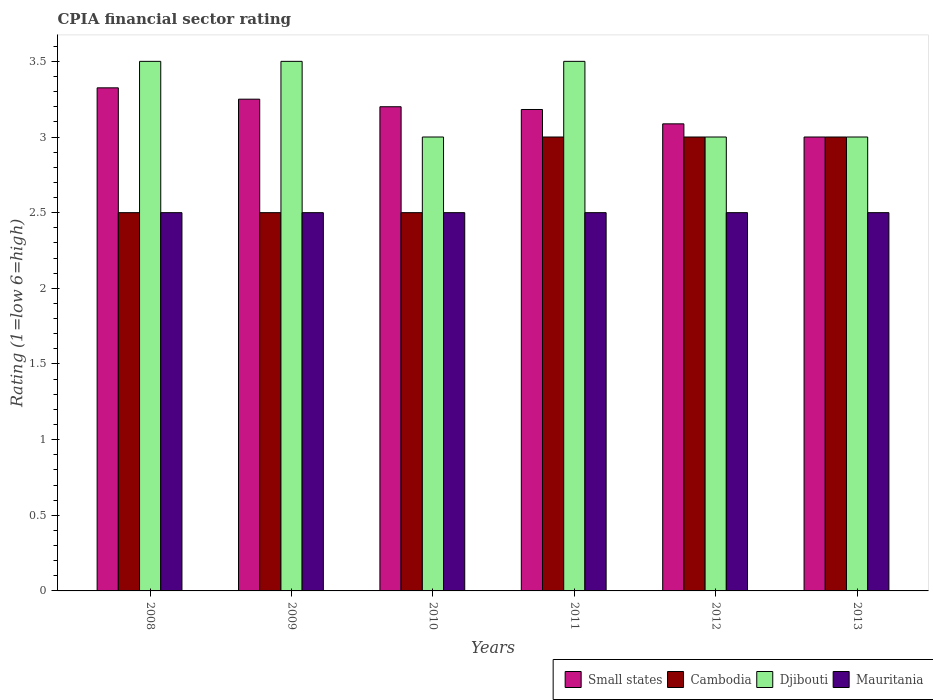Are the number of bars on each tick of the X-axis equal?
Your answer should be compact. Yes. How many bars are there on the 3rd tick from the right?
Make the answer very short. 4. In how many cases, is the number of bars for a given year not equal to the number of legend labels?
Your answer should be very brief. 0. What is the CPIA rating in Mauritania in 2009?
Keep it short and to the point. 2.5. Across all years, what is the maximum CPIA rating in Mauritania?
Your response must be concise. 2.5. Across all years, what is the minimum CPIA rating in Djibouti?
Your answer should be compact. 3. In which year was the CPIA rating in Mauritania maximum?
Offer a very short reply. 2008. What is the total CPIA rating in Small states in the graph?
Offer a terse response. 19.04. What is the difference between the CPIA rating in Small states in 2008 and the CPIA rating in Djibouti in 2013?
Your response must be concise. 0.33. What is the average CPIA rating in Small states per year?
Offer a very short reply. 3.17. In the year 2010, what is the difference between the CPIA rating in Small states and CPIA rating in Mauritania?
Make the answer very short. 0.7. In how many years, is the CPIA rating in Mauritania greater than 2?
Provide a succinct answer. 6. What is the ratio of the CPIA rating in Cambodia in 2008 to that in 2009?
Your response must be concise. 1. Is the CPIA rating in Cambodia in 2011 less than that in 2012?
Your response must be concise. No. Is the difference between the CPIA rating in Small states in 2008 and 2011 greater than the difference between the CPIA rating in Mauritania in 2008 and 2011?
Make the answer very short. Yes. What is the difference between the highest and the second highest CPIA rating in Djibouti?
Give a very brief answer. 0. What is the difference between the highest and the lowest CPIA rating in Mauritania?
Ensure brevity in your answer.  0. In how many years, is the CPIA rating in Small states greater than the average CPIA rating in Small states taken over all years?
Keep it short and to the point. 4. Is the sum of the CPIA rating in Small states in 2010 and 2013 greater than the maximum CPIA rating in Mauritania across all years?
Give a very brief answer. Yes. Is it the case that in every year, the sum of the CPIA rating in Djibouti and CPIA rating in Small states is greater than the sum of CPIA rating in Mauritania and CPIA rating in Cambodia?
Offer a very short reply. Yes. What does the 4th bar from the left in 2012 represents?
Provide a succinct answer. Mauritania. What does the 2nd bar from the right in 2008 represents?
Offer a terse response. Djibouti. Is it the case that in every year, the sum of the CPIA rating in Mauritania and CPIA rating in Small states is greater than the CPIA rating in Cambodia?
Offer a very short reply. Yes. How many bars are there?
Provide a short and direct response. 24. How many years are there in the graph?
Ensure brevity in your answer.  6. Are the values on the major ticks of Y-axis written in scientific E-notation?
Offer a terse response. No. Does the graph contain any zero values?
Keep it short and to the point. No. Where does the legend appear in the graph?
Your answer should be very brief. Bottom right. How many legend labels are there?
Ensure brevity in your answer.  4. How are the legend labels stacked?
Offer a very short reply. Horizontal. What is the title of the graph?
Offer a terse response. CPIA financial sector rating. What is the Rating (1=low 6=high) in Small states in 2008?
Offer a terse response. 3.33. What is the Rating (1=low 6=high) in Djibouti in 2008?
Provide a short and direct response. 3.5. What is the Rating (1=low 6=high) in Small states in 2009?
Provide a short and direct response. 3.25. What is the Rating (1=low 6=high) of Djibouti in 2009?
Offer a terse response. 3.5. What is the Rating (1=low 6=high) in Small states in 2010?
Give a very brief answer. 3.2. What is the Rating (1=low 6=high) of Cambodia in 2010?
Your answer should be compact. 2.5. What is the Rating (1=low 6=high) of Small states in 2011?
Ensure brevity in your answer.  3.18. What is the Rating (1=low 6=high) in Cambodia in 2011?
Keep it short and to the point. 3. What is the Rating (1=low 6=high) of Small states in 2012?
Give a very brief answer. 3.09. What is the Rating (1=low 6=high) in Djibouti in 2012?
Offer a very short reply. 3. What is the Rating (1=low 6=high) of Small states in 2013?
Provide a short and direct response. 3. What is the Rating (1=low 6=high) in Cambodia in 2013?
Your answer should be compact. 3. What is the Rating (1=low 6=high) in Mauritania in 2013?
Make the answer very short. 2.5. Across all years, what is the maximum Rating (1=low 6=high) of Small states?
Provide a succinct answer. 3.33. Across all years, what is the maximum Rating (1=low 6=high) in Cambodia?
Your answer should be compact. 3. Across all years, what is the maximum Rating (1=low 6=high) in Mauritania?
Your response must be concise. 2.5. Across all years, what is the minimum Rating (1=low 6=high) in Djibouti?
Make the answer very short. 3. What is the total Rating (1=low 6=high) in Small states in the graph?
Offer a terse response. 19.04. What is the total Rating (1=low 6=high) of Cambodia in the graph?
Offer a very short reply. 16.5. What is the difference between the Rating (1=low 6=high) in Small states in 2008 and that in 2009?
Your answer should be compact. 0.07. What is the difference between the Rating (1=low 6=high) in Mauritania in 2008 and that in 2009?
Your response must be concise. 0. What is the difference between the Rating (1=low 6=high) in Small states in 2008 and that in 2010?
Provide a short and direct response. 0.12. What is the difference between the Rating (1=low 6=high) of Cambodia in 2008 and that in 2010?
Your response must be concise. 0. What is the difference between the Rating (1=low 6=high) in Mauritania in 2008 and that in 2010?
Keep it short and to the point. 0. What is the difference between the Rating (1=low 6=high) of Small states in 2008 and that in 2011?
Keep it short and to the point. 0.14. What is the difference between the Rating (1=low 6=high) of Small states in 2008 and that in 2012?
Your response must be concise. 0.24. What is the difference between the Rating (1=low 6=high) in Small states in 2008 and that in 2013?
Provide a short and direct response. 0.33. What is the difference between the Rating (1=low 6=high) of Cambodia in 2008 and that in 2013?
Your answer should be compact. -0.5. What is the difference between the Rating (1=low 6=high) in Djibouti in 2008 and that in 2013?
Your answer should be very brief. 0.5. What is the difference between the Rating (1=low 6=high) of Small states in 2009 and that in 2010?
Provide a short and direct response. 0.05. What is the difference between the Rating (1=low 6=high) of Cambodia in 2009 and that in 2010?
Offer a very short reply. 0. What is the difference between the Rating (1=low 6=high) in Djibouti in 2009 and that in 2010?
Your answer should be compact. 0.5. What is the difference between the Rating (1=low 6=high) of Mauritania in 2009 and that in 2010?
Provide a short and direct response. 0. What is the difference between the Rating (1=low 6=high) in Small states in 2009 and that in 2011?
Ensure brevity in your answer.  0.07. What is the difference between the Rating (1=low 6=high) in Djibouti in 2009 and that in 2011?
Keep it short and to the point. 0. What is the difference between the Rating (1=low 6=high) in Small states in 2009 and that in 2012?
Your answer should be compact. 0.16. What is the difference between the Rating (1=low 6=high) in Djibouti in 2009 and that in 2012?
Your response must be concise. 0.5. What is the difference between the Rating (1=low 6=high) of Mauritania in 2009 and that in 2012?
Make the answer very short. 0. What is the difference between the Rating (1=low 6=high) of Small states in 2009 and that in 2013?
Your answer should be very brief. 0.25. What is the difference between the Rating (1=low 6=high) in Cambodia in 2009 and that in 2013?
Provide a short and direct response. -0.5. What is the difference between the Rating (1=low 6=high) of Small states in 2010 and that in 2011?
Your answer should be very brief. 0.02. What is the difference between the Rating (1=low 6=high) of Djibouti in 2010 and that in 2011?
Offer a very short reply. -0.5. What is the difference between the Rating (1=low 6=high) in Small states in 2010 and that in 2012?
Provide a short and direct response. 0.11. What is the difference between the Rating (1=low 6=high) of Mauritania in 2010 and that in 2012?
Your answer should be very brief. 0. What is the difference between the Rating (1=low 6=high) in Mauritania in 2010 and that in 2013?
Offer a very short reply. 0. What is the difference between the Rating (1=low 6=high) in Small states in 2011 and that in 2012?
Offer a terse response. 0.09. What is the difference between the Rating (1=low 6=high) in Cambodia in 2011 and that in 2012?
Ensure brevity in your answer.  0. What is the difference between the Rating (1=low 6=high) in Small states in 2011 and that in 2013?
Offer a terse response. 0.18. What is the difference between the Rating (1=low 6=high) of Cambodia in 2011 and that in 2013?
Offer a terse response. 0. What is the difference between the Rating (1=low 6=high) in Djibouti in 2011 and that in 2013?
Offer a terse response. 0.5. What is the difference between the Rating (1=low 6=high) of Mauritania in 2011 and that in 2013?
Keep it short and to the point. 0. What is the difference between the Rating (1=low 6=high) of Small states in 2012 and that in 2013?
Give a very brief answer. 0.09. What is the difference between the Rating (1=low 6=high) of Mauritania in 2012 and that in 2013?
Your answer should be compact. 0. What is the difference between the Rating (1=low 6=high) of Small states in 2008 and the Rating (1=low 6=high) of Cambodia in 2009?
Give a very brief answer. 0.82. What is the difference between the Rating (1=low 6=high) of Small states in 2008 and the Rating (1=low 6=high) of Djibouti in 2009?
Offer a terse response. -0.17. What is the difference between the Rating (1=low 6=high) of Small states in 2008 and the Rating (1=low 6=high) of Mauritania in 2009?
Provide a short and direct response. 0.82. What is the difference between the Rating (1=low 6=high) of Cambodia in 2008 and the Rating (1=low 6=high) of Mauritania in 2009?
Offer a terse response. 0. What is the difference between the Rating (1=low 6=high) in Small states in 2008 and the Rating (1=low 6=high) in Cambodia in 2010?
Your response must be concise. 0.82. What is the difference between the Rating (1=low 6=high) in Small states in 2008 and the Rating (1=low 6=high) in Djibouti in 2010?
Provide a succinct answer. 0.33. What is the difference between the Rating (1=low 6=high) in Small states in 2008 and the Rating (1=low 6=high) in Mauritania in 2010?
Give a very brief answer. 0.82. What is the difference between the Rating (1=low 6=high) in Small states in 2008 and the Rating (1=low 6=high) in Cambodia in 2011?
Keep it short and to the point. 0.33. What is the difference between the Rating (1=low 6=high) in Small states in 2008 and the Rating (1=low 6=high) in Djibouti in 2011?
Ensure brevity in your answer.  -0.17. What is the difference between the Rating (1=low 6=high) in Small states in 2008 and the Rating (1=low 6=high) in Mauritania in 2011?
Your answer should be very brief. 0.82. What is the difference between the Rating (1=low 6=high) of Cambodia in 2008 and the Rating (1=low 6=high) of Mauritania in 2011?
Offer a very short reply. 0. What is the difference between the Rating (1=low 6=high) in Djibouti in 2008 and the Rating (1=low 6=high) in Mauritania in 2011?
Make the answer very short. 1. What is the difference between the Rating (1=low 6=high) of Small states in 2008 and the Rating (1=low 6=high) of Cambodia in 2012?
Provide a short and direct response. 0.33. What is the difference between the Rating (1=low 6=high) of Small states in 2008 and the Rating (1=low 6=high) of Djibouti in 2012?
Your answer should be compact. 0.33. What is the difference between the Rating (1=low 6=high) in Small states in 2008 and the Rating (1=low 6=high) in Mauritania in 2012?
Provide a succinct answer. 0.82. What is the difference between the Rating (1=low 6=high) of Cambodia in 2008 and the Rating (1=low 6=high) of Djibouti in 2012?
Offer a very short reply. -0.5. What is the difference between the Rating (1=low 6=high) in Small states in 2008 and the Rating (1=low 6=high) in Cambodia in 2013?
Provide a succinct answer. 0.33. What is the difference between the Rating (1=low 6=high) of Small states in 2008 and the Rating (1=low 6=high) of Djibouti in 2013?
Make the answer very short. 0.33. What is the difference between the Rating (1=low 6=high) of Small states in 2008 and the Rating (1=low 6=high) of Mauritania in 2013?
Offer a very short reply. 0.82. What is the difference between the Rating (1=low 6=high) in Cambodia in 2008 and the Rating (1=low 6=high) in Djibouti in 2013?
Make the answer very short. -0.5. What is the difference between the Rating (1=low 6=high) of Djibouti in 2008 and the Rating (1=low 6=high) of Mauritania in 2013?
Give a very brief answer. 1. What is the difference between the Rating (1=low 6=high) in Small states in 2009 and the Rating (1=low 6=high) in Cambodia in 2010?
Your answer should be very brief. 0.75. What is the difference between the Rating (1=low 6=high) of Small states in 2009 and the Rating (1=low 6=high) of Djibouti in 2010?
Provide a succinct answer. 0.25. What is the difference between the Rating (1=low 6=high) in Small states in 2009 and the Rating (1=low 6=high) in Mauritania in 2010?
Keep it short and to the point. 0.75. What is the difference between the Rating (1=low 6=high) in Djibouti in 2009 and the Rating (1=low 6=high) in Mauritania in 2010?
Provide a short and direct response. 1. What is the difference between the Rating (1=low 6=high) of Small states in 2009 and the Rating (1=low 6=high) of Cambodia in 2011?
Your response must be concise. 0.25. What is the difference between the Rating (1=low 6=high) in Small states in 2009 and the Rating (1=low 6=high) in Mauritania in 2011?
Your response must be concise. 0.75. What is the difference between the Rating (1=low 6=high) in Cambodia in 2009 and the Rating (1=low 6=high) in Djibouti in 2011?
Ensure brevity in your answer.  -1. What is the difference between the Rating (1=low 6=high) of Cambodia in 2009 and the Rating (1=low 6=high) of Mauritania in 2011?
Provide a short and direct response. 0. What is the difference between the Rating (1=low 6=high) of Djibouti in 2009 and the Rating (1=low 6=high) of Mauritania in 2011?
Give a very brief answer. 1. What is the difference between the Rating (1=low 6=high) of Small states in 2009 and the Rating (1=low 6=high) of Djibouti in 2012?
Offer a terse response. 0.25. What is the difference between the Rating (1=low 6=high) in Small states in 2009 and the Rating (1=low 6=high) in Cambodia in 2013?
Ensure brevity in your answer.  0.25. What is the difference between the Rating (1=low 6=high) in Small states in 2009 and the Rating (1=low 6=high) in Djibouti in 2013?
Keep it short and to the point. 0.25. What is the difference between the Rating (1=low 6=high) in Cambodia in 2009 and the Rating (1=low 6=high) in Mauritania in 2013?
Provide a succinct answer. 0. What is the difference between the Rating (1=low 6=high) in Cambodia in 2010 and the Rating (1=low 6=high) in Djibouti in 2011?
Keep it short and to the point. -1. What is the difference between the Rating (1=low 6=high) in Cambodia in 2010 and the Rating (1=low 6=high) in Mauritania in 2011?
Offer a terse response. 0. What is the difference between the Rating (1=low 6=high) of Djibouti in 2010 and the Rating (1=low 6=high) of Mauritania in 2011?
Give a very brief answer. 0.5. What is the difference between the Rating (1=low 6=high) in Cambodia in 2010 and the Rating (1=low 6=high) in Djibouti in 2012?
Ensure brevity in your answer.  -0.5. What is the difference between the Rating (1=low 6=high) in Djibouti in 2010 and the Rating (1=low 6=high) in Mauritania in 2012?
Your answer should be very brief. 0.5. What is the difference between the Rating (1=low 6=high) in Small states in 2010 and the Rating (1=low 6=high) in Cambodia in 2013?
Make the answer very short. 0.2. What is the difference between the Rating (1=low 6=high) in Small states in 2010 and the Rating (1=low 6=high) in Mauritania in 2013?
Offer a terse response. 0.7. What is the difference between the Rating (1=low 6=high) in Djibouti in 2010 and the Rating (1=low 6=high) in Mauritania in 2013?
Give a very brief answer. 0.5. What is the difference between the Rating (1=low 6=high) in Small states in 2011 and the Rating (1=low 6=high) in Cambodia in 2012?
Give a very brief answer. 0.18. What is the difference between the Rating (1=low 6=high) of Small states in 2011 and the Rating (1=low 6=high) of Djibouti in 2012?
Provide a succinct answer. 0.18. What is the difference between the Rating (1=low 6=high) in Small states in 2011 and the Rating (1=low 6=high) in Mauritania in 2012?
Offer a terse response. 0.68. What is the difference between the Rating (1=low 6=high) of Cambodia in 2011 and the Rating (1=low 6=high) of Djibouti in 2012?
Give a very brief answer. 0. What is the difference between the Rating (1=low 6=high) of Djibouti in 2011 and the Rating (1=low 6=high) of Mauritania in 2012?
Offer a terse response. 1. What is the difference between the Rating (1=low 6=high) in Small states in 2011 and the Rating (1=low 6=high) in Cambodia in 2013?
Ensure brevity in your answer.  0.18. What is the difference between the Rating (1=low 6=high) in Small states in 2011 and the Rating (1=low 6=high) in Djibouti in 2013?
Keep it short and to the point. 0.18. What is the difference between the Rating (1=low 6=high) in Small states in 2011 and the Rating (1=low 6=high) in Mauritania in 2013?
Your response must be concise. 0.68. What is the difference between the Rating (1=low 6=high) of Small states in 2012 and the Rating (1=low 6=high) of Cambodia in 2013?
Give a very brief answer. 0.09. What is the difference between the Rating (1=low 6=high) of Small states in 2012 and the Rating (1=low 6=high) of Djibouti in 2013?
Keep it short and to the point. 0.09. What is the difference between the Rating (1=low 6=high) of Small states in 2012 and the Rating (1=low 6=high) of Mauritania in 2013?
Your response must be concise. 0.59. What is the difference between the Rating (1=low 6=high) of Cambodia in 2012 and the Rating (1=low 6=high) of Mauritania in 2013?
Ensure brevity in your answer.  0.5. What is the average Rating (1=low 6=high) in Small states per year?
Your response must be concise. 3.17. What is the average Rating (1=low 6=high) of Cambodia per year?
Offer a very short reply. 2.75. In the year 2008, what is the difference between the Rating (1=low 6=high) in Small states and Rating (1=low 6=high) in Cambodia?
Your response must be concise. 0.82. In the year 2008, what is the difference between the Rating (1=low 6=high) of Small states and Rating (1=low 6=high) of Djibouti?
Give a very brief answer. -0.17. In the year 2008, what is the difference between the Rating (1=low 6=high) of Small states and Rating (1=low 6=high) of Mauritania?
Provide a succinct answer. 0.82. In the year 2008, what is the difference between the Rating (1=low 6=high) of Cambodia and Rating (1=low 6=high) of Mauritania?
Offer a very short reply. 0. In the year 2009, what is the difference between the Rating (1=low 6=high) of Small states and Rating (1=low 6=high) of Cambodia?
Provide a short and direct response. 0.75. In the year 2009, what is the difference between the Rating (1=low 6=high) of Small states and Rating (1=low 6=high) of Djibouti?
Offer a very short reply. -0.25. In the year 2009, what is the difference between the Rating (1=low 6=high) in Small states and Rating (1=low 6=high) in Mauritania?
Offer a terse response. 0.75. In the year 2009, what is the difference between the Rating (1=low 6=high) in Cambodia and Rating (1=low 6=high) in Mauritania?
Provide a succinct answer. 0. In the year 2009, what is the difference between the Rating (1=low 6=high) in Djibouti and Rating (1=low 6=high) in Mauritania?
Your answer should be very brief. 1. In the year 2010, what is the difference between the Rating (1=low 6=high) of Small states and Rating (1=low 6=high) of Cambodia?
Give a very brief answer. 0.7. In the year 2010, what is the difference between the Rating (1=low 6=high) in Cambodia and Rating (1=low 6=high) in Djibouti?
Ensure brevity in your answer.  -0.5. In the year 2010, what is the difference between the Rating (1=low 6=high) in Djibouti and Rating (1=low 6=high) in Mauritania?
Offer a terse response. 0.5. In the year 2011, what is the difference between the Rating (1=low 6=high) in Small states and Rating (1=low 6=high) in Cambodia?
Your answer should be very brief. 0.18. In the year 2011, what is the difference between the Rating (1=low 6=high) in Small states and Rating (1=low 6=high) in Djibouti?
Your answer should be compact. -0.32. In the year 2011, what is the difference between the Rating (1=low 6=high) of Small states and Rating (1=low 6=high) of Mauritania?
Provide a short and direct response. 0.68. In the year 2011, what is the difference between the Rating (1=low 6=high) of Cambodia and Rating (1=low 6=high) of Djibouti?
Offer a very short reply. -0.5. In the year 2011, what is the difference between the Rating (1=low 6=high) in Djibouti and Rating (1=low 6=high) in Mauritania?
Make the answer very short. 1. In the year 2012, what is the difference between the Rating (1=low 6=high) in Small states and Rating (1=low 6=high) in Cambodia?
Offer a very short reply. 0.09. In the year 2012, what is the difference between the Rating (1=low 6=high) in Small states and Rating (1=low 6=high) in Djibouti?
Offer a terse response. 0.09. In the year 2012, what is the difference between the Rating (1=low 6=high) of Small states and Rating (1=low 6=high) of Mauritania?
Provide a short and direct response. 0.59. In the year 2012, what is the difference between the Rating (1=low 6=high) in Djibouti and Rating (1=low 6=high) in Mauritania?
Provide a short and direct response. 0.5. In the year 2013, what is the difference between the Rating (1=low 6=high) of Small states and Rating (1=low 6=high) of Cambodia?
Keep it short and to the point. 0. In the year 2013, what is the difference between the Rating (1=low 6=high) in Small states and Rating (1=low 6=high) in Mauritania?
Your answer should be compact. 0.5. In the year 2013, what is the difference between the Rating (1=low 6=high) in Cambodia and Rating (1=low 6=high) in Djibouti?
Provide a succinct answer. 0. In the year 2013, what is the difference between the Rating (1=low 6=high) of Cambodia and Rating (1=low 6=high) of Mauritania?
Give a very brief answer. 0.5. In the year 2013, what is the difference between the Rating (1=low 6=high) in Djibouti and Rating (1=low 6=high) in Mauritania?
Provide a succinct answer. 0.5. What is the ratio of the Rating (1=low 6=high) of Small states in 2008 to that in 2009?
Provide a short and direct response. 1.02. What is the ratio of the Rating (1=low 6=high) in Cambodia in 2008 to that in 2009?
Make the answer very short. 1. What is the ratio of the Rating (1=low 6=high) of Djibouti in 2008 to that in 2009?
Your response must be concise. 1. What is the ratio of the Rating (1=low 6=high) of Small states in 2008 to that in 2010?
Give a very brief answer. 1.04. What is the ratio of the Rating (1=low 6=high) of Cambodia in 2008 to that in 2010?
Give a very brief answer. 1. What is the ratio of the Rating (1=low 6=high) in Small states in 2008 to that in 2011?
Provide a succinct answer. 1.04. What is the ratio of the Rating (1=low 6=high) of Djibouti in 2008 to that in 2011?
Provide a succinct answer. 1. What is the ratio of the Rating (1=low 6=high) of Small states in 2008 to that in 2012?
Your answer should be very brief. 1.08. What is the ratio of the Rating (1=low 6=high) in Cambodia in 2008 to that in 2012?
Provide a short and direct response. 0.83. What is the ratio of the Rating (1=low 6=high) of Mauritania in 2008 to that in 2012?
Provide a short and direct response. 1. What is the ratio of the Rating (1=low 6=high) in Small states in 2008 to that in 2013?
Your response must be concise. 1.11. What is the ratio of the Rating (1=low 6=high) in Djibouti in 2008 to that in 2013?
Offer a terse response. 1.17. What is the ratio of the Rating (1=low 6=high) in Mauritania in 2008 to that in 2013?
Make the answer very short. 1. What is the ratio of the Rating (1=low 6=high) of Small states in 2009 to that in 2010?
Provide a succinct answer. 1.02. What is the ratio of the Rating (1=low 6=high) in Djibouti in 2009 to that in 2010?
Give a very brief answer. 1.17. What is the ratio of the Rating (1=low 6=high) of Small states in 2009 to that in 2011?
Your answer should be very brief. 1.02. What is the ratio of the Rating (1=low 6=high) of Djibouti in 2009 to that in 2011?
Provide a succinct answer. 1. What is the ratio of the Rating (1=low 6=high) in Mauritania in 2009 to that in 2011?
Keep it short and to the point. 1. What is the ratio of the Rating (1=low 6=high) of Small states in 2009 to that in 2012?
Provide a short and direct response. 1.05. What is the ratio of the Rating (1=low 6=high) in Cambodia in 2009 to that in 2013?
Make the answer very short. 0.83. What is the ratio of the Rating (1=low 6=high) in Mauritania in 2009 to that in 2013?
Offer a terse response. 1. What is the ratio of the Rating (1=low 6=high) in Small states in 2010 to that in 2011?
Keep it short and to the point. 1.01. What is the ratio of the Rating (1=low 6=high) in Cambodia in 2010 to that in 2011?
Make the answer very short. 0.83. What is the ratio of the Rating (1=low 6=high) of Small states in 2010 to that in 2012?
Your response must be concise. 1.04. What is the ratio of the Rating (1=low 6=high) in Djibouti in 2010 to that in 2012?
Your response must be concise. 1. What is the ratio of the Rating (1=low 6=high) in Mauritania in 2010 to that in 2012?
Give a very brief answer. 1. What is the ratio of the Rating (1=low 6=high) in Small states in 2010 to that in 2013?
Give a very brief answer. 1.07. What is the ratio of the Rating (1=low 6=high) in Cambodia in 2010 to that in 2013?
Provide a short and direct response. 0.83. What is the ratio of the Rating (1=low 6=high) in Small states in 2011 to that in 2012?
Your response must be concise. 1.03. What is the ratio of the Rating (1=low 6=high) in Cambodia in 2011 to that in 2012?
Make the answer very short. 1. What is the ratio of the Rating (1=low 6=high) of Mauritania in 2011 to that in 2012?
Provide a short and direct response. 1. What is the ratio of the Rating (1=low 6=high) in Small states in 2011 to that in 2013?
Give a very brief answer. 1.06. What is the ratio of the Rating (1=low 6=high) in Cambodia in 2011 to that in 2013?
Your response must be concise. 1. What is the ratio of the Rating (1=low 6=high) of Mauritania in 2011 to that in 2013?
Keep it short and to the point. 1. What is the ratio of the Rating (1=low 6=high) of Djibouti in 2012 to that in 2013?
Offer a very short reply. 1. What is the difference between the highest and the second highest Rating (1=low 6=high) of Small states?
Make the answer very short. 0.07. What is the difference between the highest and the second highest Rating (1=low 6=high) of Cambodia?
Your answer should be very brief. 0. What is the difference between the highest and the second highest Rating (1=low 6=high) in Djibouti?
Offer a very short reply. 0. What is the difference between the highest and the lowest Rating (1=low 6=high) of Small states?
Keep it short and to the point. 0.33. What is the difference between the highest and the lowest Rating (1=low 6=high) of Djibouti?
Your answer should be compact. 0.5. What is the difference between the highest and the lowest Rating (1=low 6=high) of Mauritania?
Give a very brief answer. 0. 